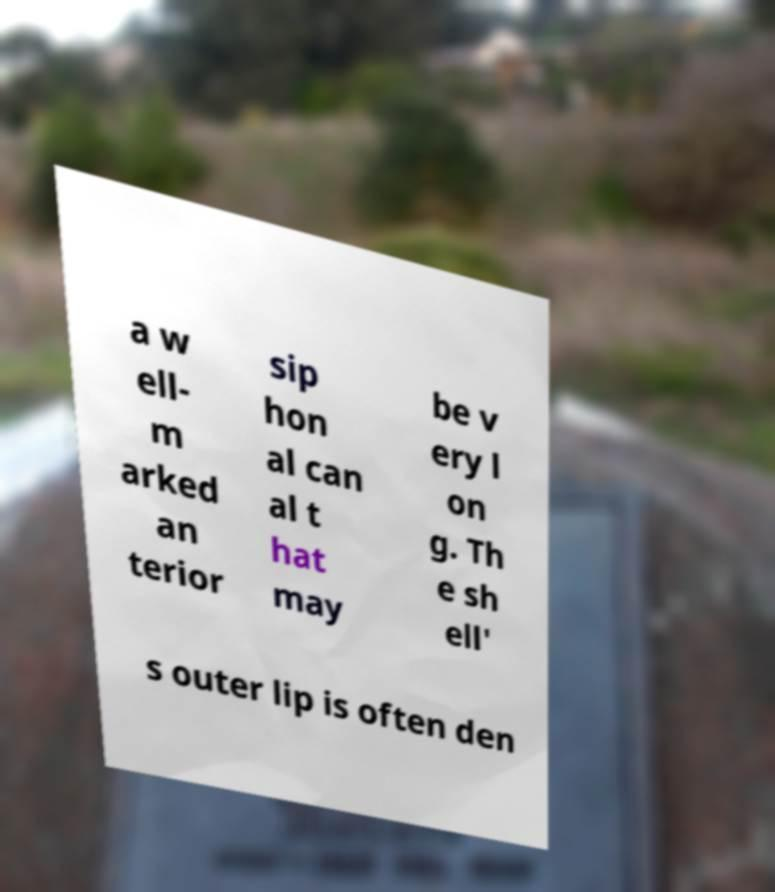There's text embedded in this image that I need extracted. Can you transcribe it verbatim? a w ell- m arked an terior sip hon al can al t hat may be v ery l on g. Th e sh ell' s outer lip is often den 